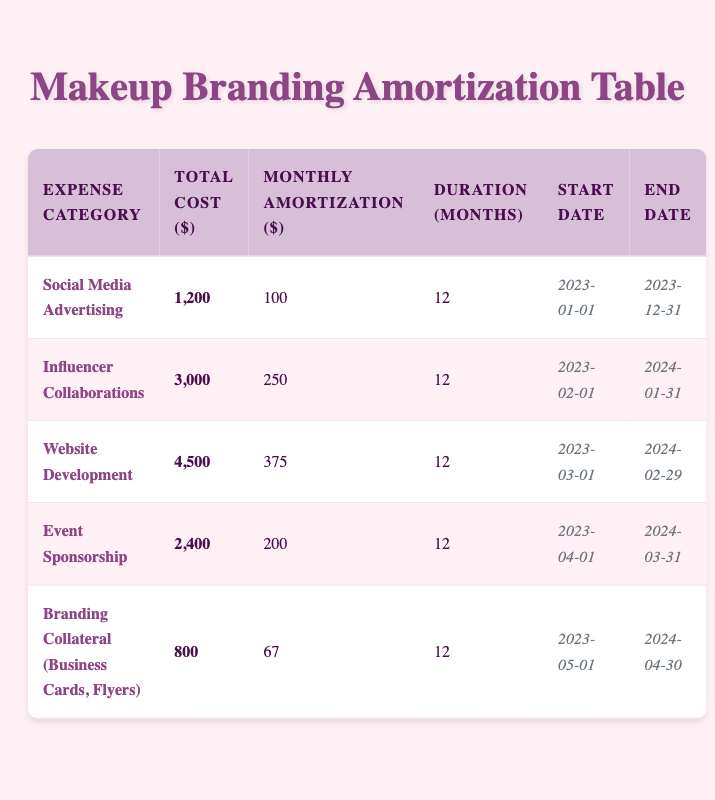What is the total cost of the "Website Development" expense? From the table, we can directly see the "Website Development" expense category listed under "Total Cost ($)" which is 4,500.
Answer: 4,500 How much is the monthly amortization for "Influencer Collaborations"? Looking at the "Influencer Collaborations" row, the "Monthly Amortization ($)" listed is 250.
Answer: 250 What is the duration in months for "Event Sponsorship"? The duration for "Event Sponsorship" can be found in its row, and it shows 12 months.
Answer: 12 Is the total cost of "Branding Collateral" less than 1,000 dollars? Checking the "Branding Collateral" total cost, which is 800, we see that it is indeed less than 1,000.
Answer: Yes Which expense category has the highest monthly amortization? From reviewing the table, we compare the "Monthly Amortization" values and find that "Website Development" has the highest at 375.
Answer: Website Development What is the total of the monthly amortization amounts for all expense categories? We add together all the monthly amortization values: 100 + 250 + 375 + 200 + 67 = 992.
Answer: 992 How many expense categories have a total cost greater than 2,000? We look at the total costs and find "Influencer Collaborations" (3,000) and "Website Development" (4,500), both are greater than 2,000, totaling two categories.
Answer: 2 What is the difference between the total costs of "Social Media Advertising" and "Event Sponsorship"? We subtract the total cost of "Event Sponsorship" (2,400) from "Social Media Advertising" (1,200): 2,400 - 1,200 = 1,200.
Answer: 1,200 If a makeup artist starts a new expense in June, what expenses will they have already incurred by then based on the start dates? By June, the artist will have incurred "Social Media Advertising," "Influencer Collaborations," and "Website Development," since they started in January, February, and March respectively.
Answer: 3 